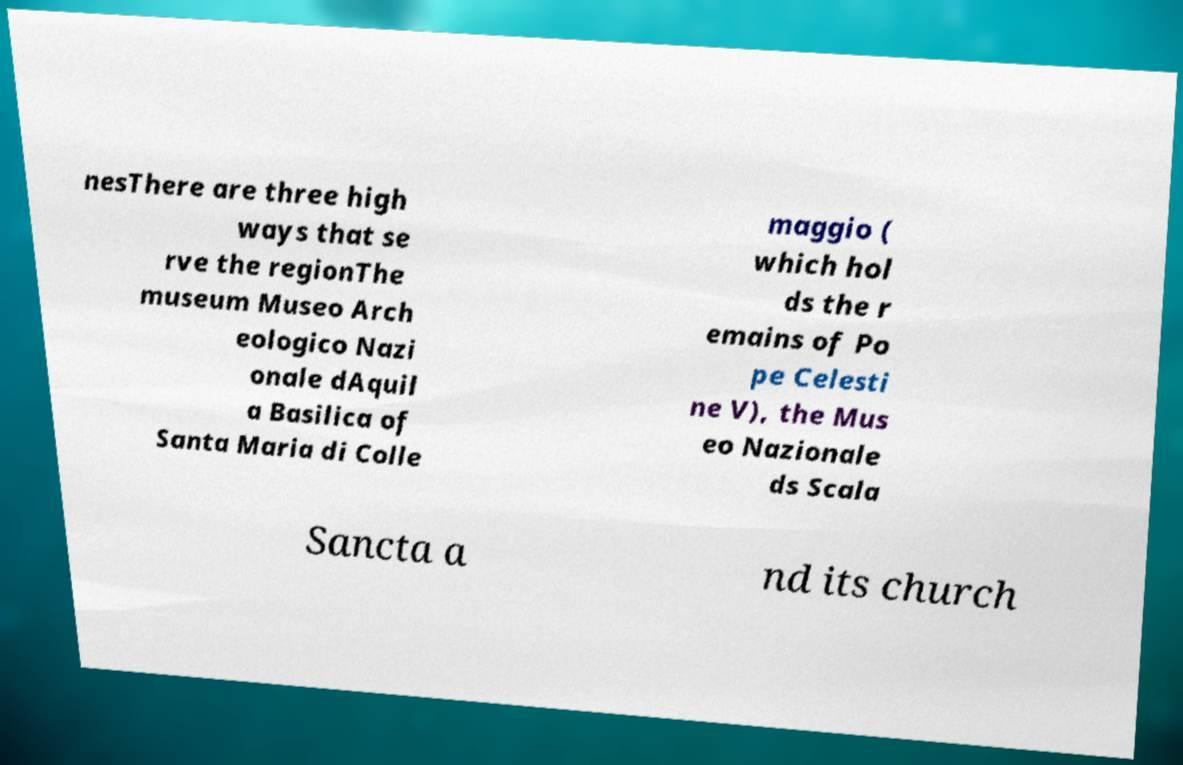Please identify and transcribe the text found in this image. nesThere are three high ways that se rve the regionThe museum Museo Arch eologico Nazi onale dAquil a Basilica of Santa Maria di Colle maggio ( which hol ds the r emains of Po pe Celesti ne V), the Mus eo Nazionale ds Scala Sancta a nd its church 